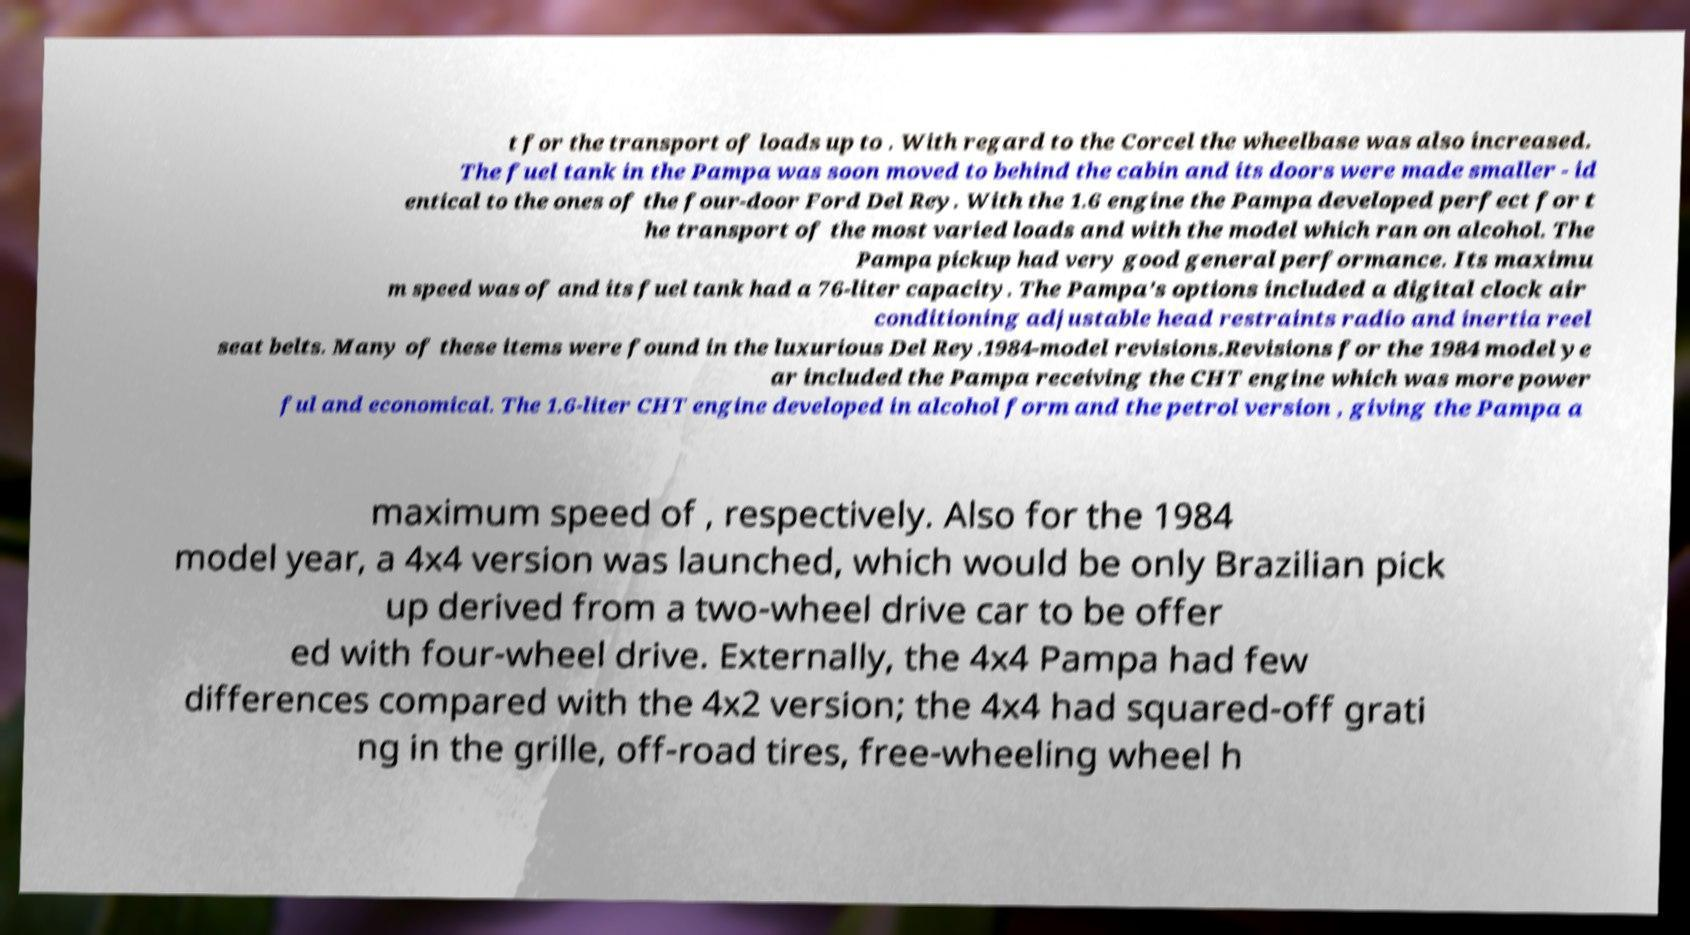What messages or text are displayed in this image? I need them in a readable, typed format. t for the transport of loads up to . With regard to the Corcel the wheelbase was also increased. The fuel tank in the Pampa was soon moved to behind the cabin and its doors were made smaller - id entical to the ones of the four-door Ford Del Rey. With the 1.6 engine the Pampa developed perfect for t he transport of the most varied loads and with the model which ran on alcohol. The Pampa pickup had very good general performance. Its maximu m speed was of and its fuel tank had a 76-liter capacity. The Pampa’s options included a digital clock air conditioning adjustable head restraints radio and inertia reel seat belts. Many of these items were found in the luxurious Del Rey.1984-model revisions.Revisions for the 1984 model ye ar included the Pampa receiving the CHT engine which was more power ful and economical. The 1.6-liter CHT engine developed in alcohol form and the petrol version , giving the Pampa a maximum speed of , respectively. Also for the 1984 model year, a 4x4 version was launched, which would be only Brazilian pick up derived from a two-wheel drive car to be offer ed with four-wheel drive. Externally, the 4x4 Pampa had few differences compared with the 4x2 version; the 4x4 had squared-off grati ng in the grille, off-road tires, free-wheeling wheel h 